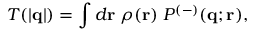<formula> <loc_0><loc_0><loc_500><loc_500>T ( | { q } | ) = \int d { r } \, \rho ( { r } ) \, P ^ { ( - ) } ( { q } ; { r } ) ,</formula> 